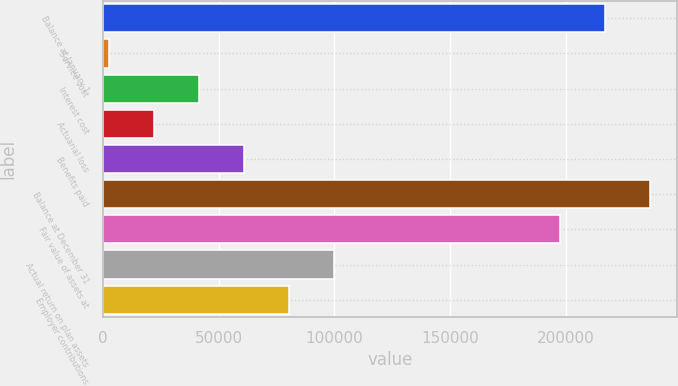Convert chart to OTSL. <chart><loc_0><loc_0><loc_500><loc_500><bar_chart><fcel>Balance at January 1<fcel>Service cost<fcel>Interest cost<fcel>Actuarial loss<fcel>Benefits paid<fcel>Balance at December 31<fcel>Fair value of assets at<fcel>Actual return on plan assets<fcel>Employer contributions<nl><fcel>216948<fcel>2625<fcel>41592.8<fcel>22108.9<fcel>61076.7<fcel>236432<fcel>197464<fcel>100044<fcel>80560.6<nl></chart> 